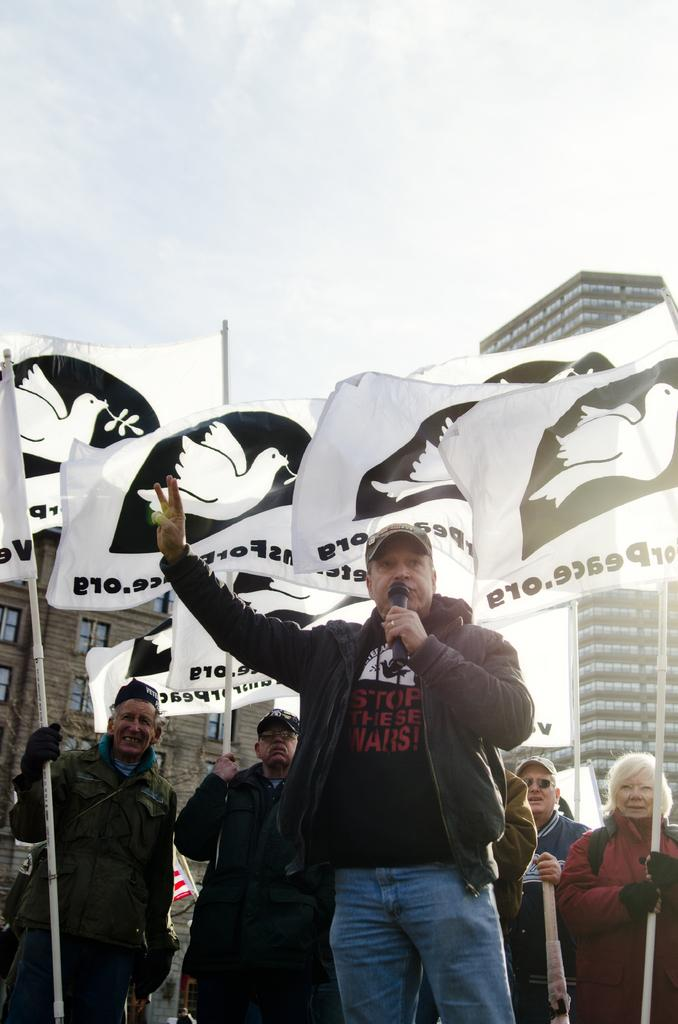What is the person in the image holding? The person in the image is holding a microphone. What are the other people holding in the image? The other people in the image are holding flags. What can be seen in the background of the image? There are buildings and the sky visible in the background of the image. How does the person holding the microphone feel about their selection of heat-resistant clothing in the image? There is no information about heat-resistant clothing or any selection process in the image, so it cannot be determined how the person feels about it. 